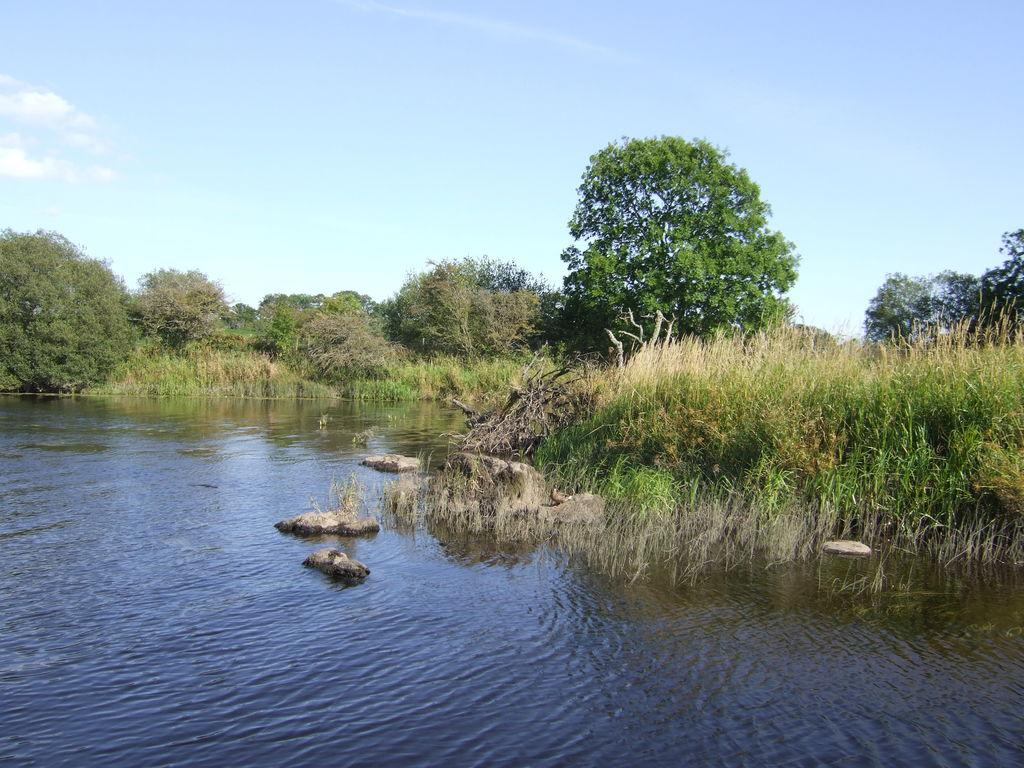What is the primary element visible in the image? There is water in the image. What other natural elements can be seen in the image? There are rocks and grass on the surface in the image. What can be seen in the background of the image? There are trees and sky visible in the background of the image. What type of degree is being awarded to the person in the image? There is no person present in the image, and therefore no degree being awarded. Can you hear the sound of thunder in the image? There is no sound present in the image, and therefore no thunder can be heard. 